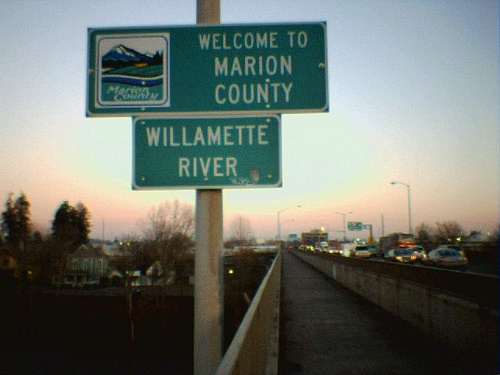Describe the objects in this image and their specific colors. I can see car in darkgray, black, gray, darkgreen, and maroon tones, car in darkgray, black, gray, olive, and maroon tones, car in darkgray, black, gray, olive, and teal tones, car in darkgray, black, tan, olive, and gray tones, and car in darkgray, gray, tan, and black tones in this image. 